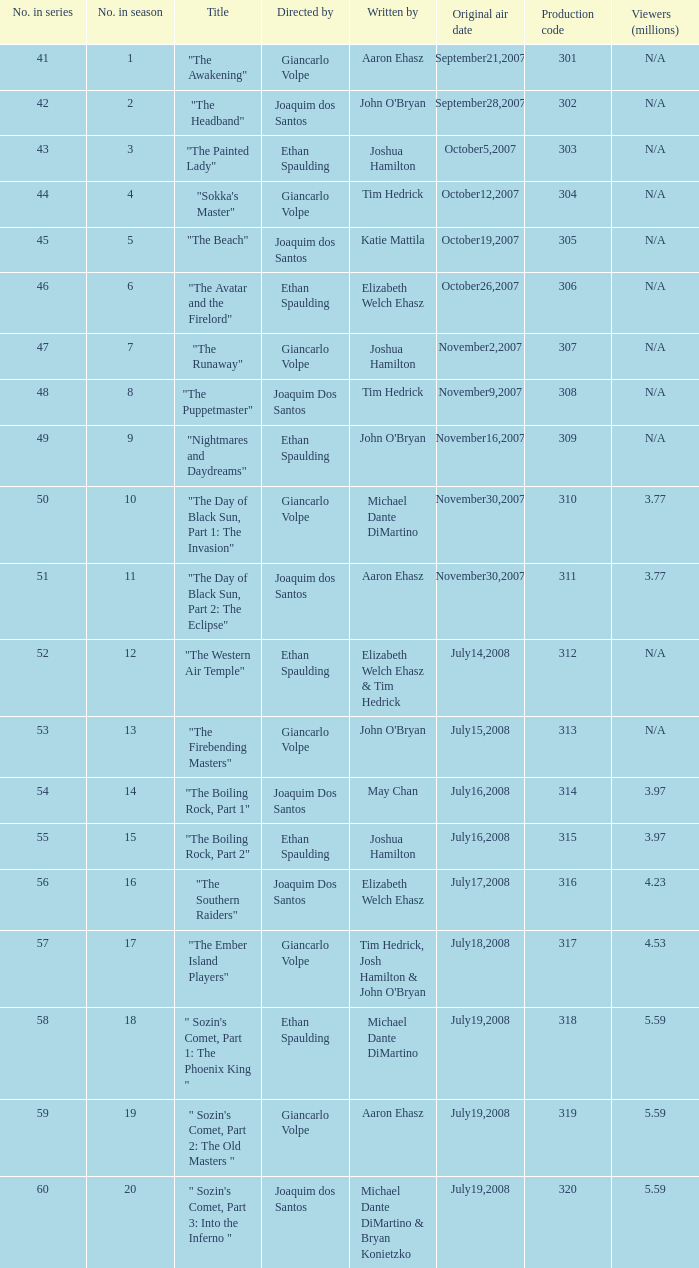How many viewers in millions for episode "sokka's master"? N/A. 